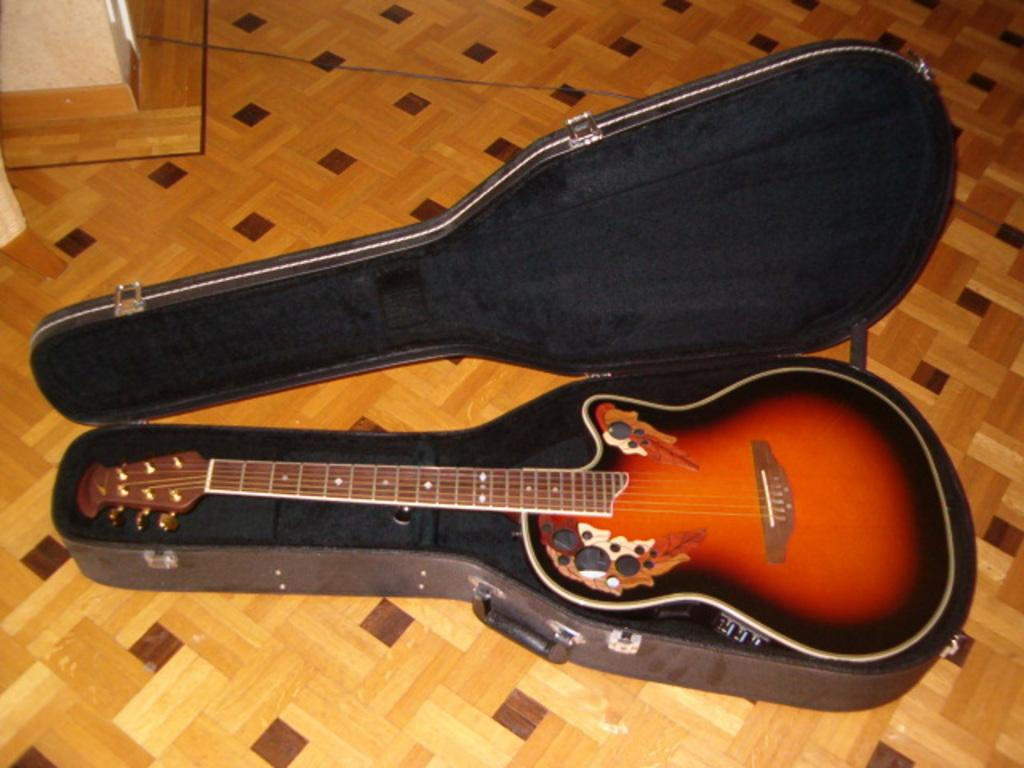Where was the image taken? The image was taken inside a room. What object is in the guitar box? There is a guitar in the guitar box. What color is the guitar? The guitar is red. What color is the floor in the room? The floor is brown. What type of glove can be seen playing the red guitar in the image? There is no glove playing the guitar in the image; it is a still image of a guitar in a guitar box. Can you tell me how many cards are on the floor in the image? There are no cards present on the floor in the image; the floor is brown, and the only visible object is a guitar in a guitar box. 